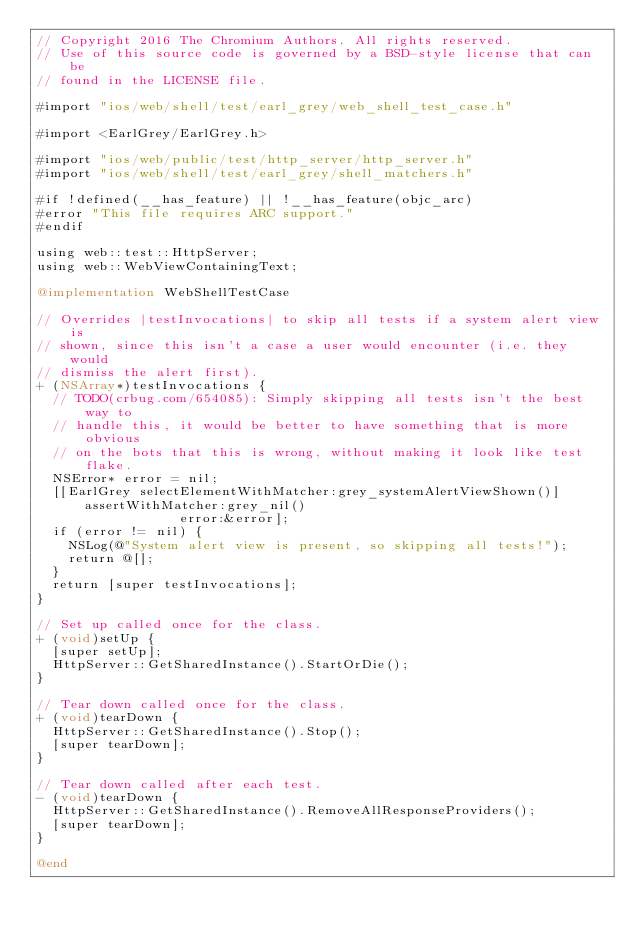Convert code to text. <code><loc_0><loc_0><loc_500><loc_500><_ObjectiveC_>// Copyright 2016 The Chromium Authors. All rights reserved.
// Use of this source code is governed by a BSD-style license that can be
// found in the LICENSE file.

#import "ios/web/shell/test/earl_grey/web_shell_test_case.h"

#import <EarlGrey/EarlGrey.h>

#import "ios/web/public/test/http_server/http_server.h"
#import "ios/web/shell/test/earl_grey/shell_matchers.h"

#if !defined(__has_feature) || !__has_feature(objc_arc)
#error "This file requires ARC support."
#endif

using web::test::HttpServer;
using web::WebViewContainingText;

@implementation WebShellTestCase

// Overrides |testInvocations| to skip all tests if a system alert view is
// shown, since this isn't a case a user would encounter (i.e. they would
// dismiss the alert first).
+ (NSArray*)testInvocations {
  // TODO(crbug.com/654085): Simply skipping all tests isn't the best way to
  // handle this, it would be better to have something that is more obvious
  // on the bots that this is wrong, without making it look like test flake.
  NSError* error = nil;
  [[EarlGrey selectElementWithMatcher:grey_systemAlertViewShown()]
      assertWithMatcher:grey_nil()
                  error:&error];
  if (error != nil) {
    NSLog(@"System alert view is present, so skipping all tests!");
    return @[];
  }
  return [super testInvocations];
}

// Set up called once for the class.
+ (void)setUp {
  [super setUp];
  HttpServer::GetSharedInstance().StartOrDie();
}

// Tear down called once for the class.
+ (void)tearDown {
  HttpServer::GetSharedInstance().Stop();
  [super tearDown];
}

// Tear down called after each test.
- (void)tearDown {
  HttpServer::GetSharedInstance().RemoveAllResponseProviders();
  [super tearDown];
}

@end
</code> 